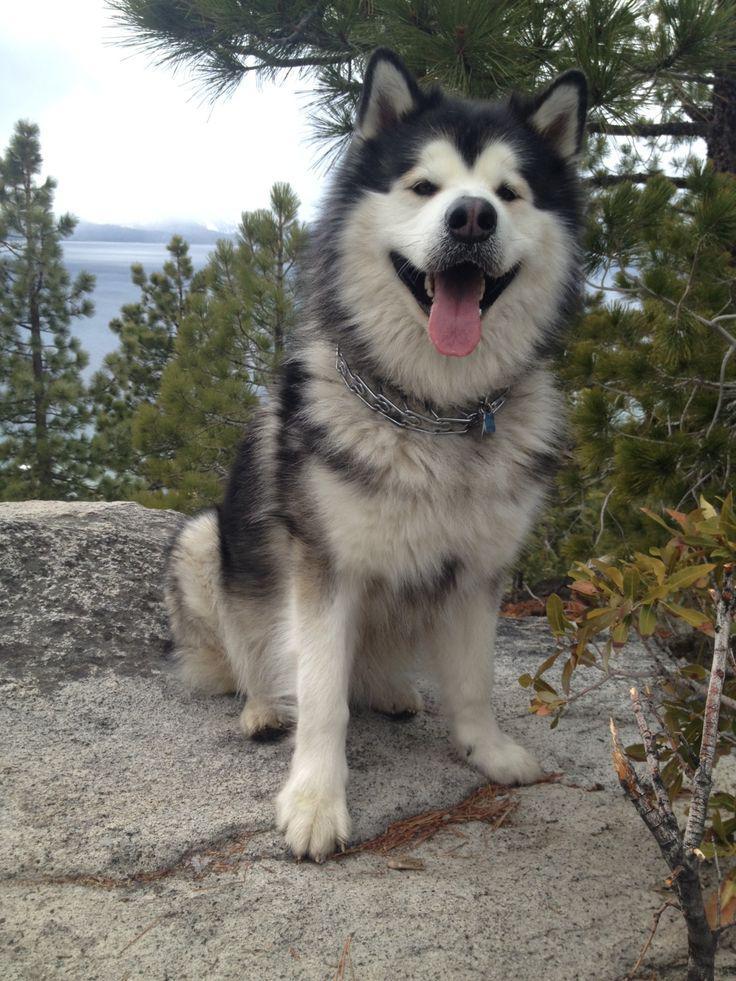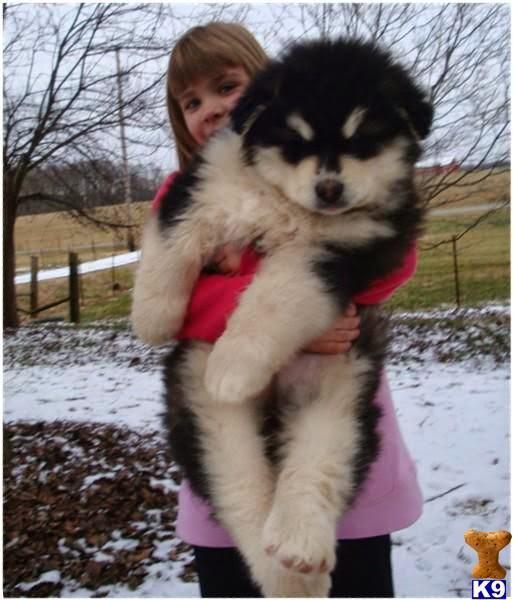The first image is the image on the left, the second image is the image on the right. Evaluate the accuracy of this statement regarding the images: "A dog is sitting.". Is it true? Answer yes or no. Yes. The first image is the image on the left, the second image is the image on the right. Evaluate the accuracy of this statement regarding the images: "Each image includes a black-and-white husky with an open mouth, and at least one image includes a dog reclining on its belly with its front paws extended.". Is it true? Answer yes or no. No. 